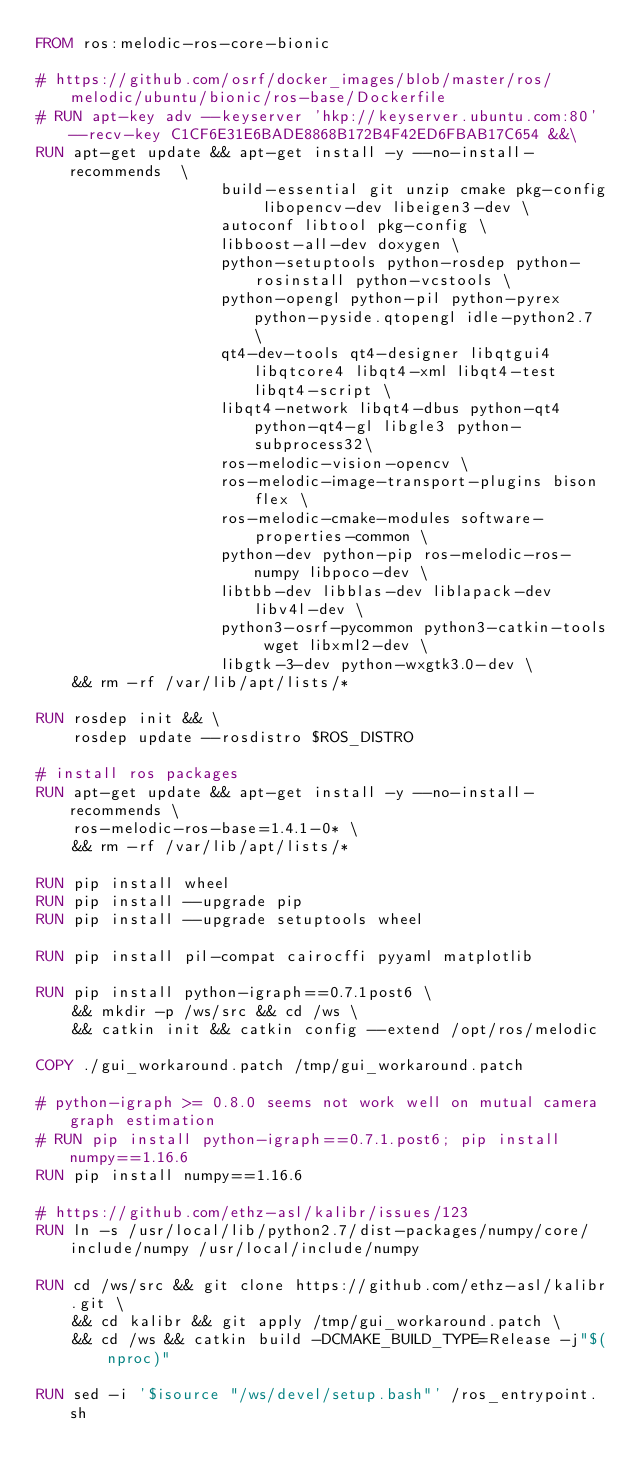Convert code to text. <code><loc_0><loc_0><loc_500><loc_500><_Dockerfile_>FROM ros:melodic-ros-core-bionic

# https://github.com/osrf/docker_images/blob/master/ros/melodic/ubuntu/bionic/ros-base/Dockerfile
# RUN apt-key adv --keyserver 'hkp://keyserver.ubuntu.com:80' --recv-key C1CF6E31E6BADE8868B172B4F42ED6FBAB17C654 &&\
RUN apt-get update && apt-get install -y --no-install-recommends  \
                    build-essential git unzip cmake pkg-config libopencv-dev libeigen3-dev \
                    autoconf libtool pkg-config \
                    libboost-all-dev doxygen \
                    python-setuptools python-rosdep python-rosinstall python-vcstools \
                    python-opengl python-pil python-pyrex python-pyside.qtopengl idle-python2.7 \
                    qt4-dev-tools qt4-designer libqtgui4 libqtcore4 libqt4-xml libqt4-test libqt4-script \
                    libqt4-network libqt4-dbus python-qt4 python-qt4-gl libgle3 python-subprocess32\
                    ros-melodic-vision-opencv \
                    ros-melodic-image-transport-plugins bison flex \
                    ros-melodic-cmake-modules software-properties-common \
                    python-dev python-pip ros-melodic-ros-numpy libpoco-dev \
                    libtbb-dev libblas-dev liblapack-dev libv4l-dev \
                    python3-osrf-pycommon python3-catkin-tools wget libxml2-dev \
                    libgtk-3-dev python-wxgtk3.0-dev \
    && rm -rf /var/lib/apt/lists/*

RUN rosdep init && \
    rosdep update --rosdistro $ROS_DISTRO

# install ros packages
RUN apt-get update && apt-get install -y --no-install-recommends \
    ros-melodic-ros-base=1.4.1-0* \
    && rm -rf /var/lib/apt/lists/*

RUN pip install wheel
RUN pip install --upgrade pip
RUN pip install --upgrade setuptools wheel

RUN pip install pil-compat cairocffi pyyaml matplotlib

RUN pip install python-igraph==0.7.1post6 \
    && mkdir -p /ws/src && cd /ws \
    && catkin init && catkin config --extend /opt/ros/melodic

COPY ./gui_workaround.patch /tmp/gui_workaround.patch

# python-igraph >= 0.8.0 seems not work well on mutual camera graph estimation
# RUN pip install python-igraph==0.7.1.post6; pip install numpy==1.16.6
RUN pip install numpy==1.16.6

# https://github.com/ethz-asl/kalibr/issues/123
RUN ln -s /usr/local/lib/python2.7/dist-packages/numpy/core/include/numpy /usr/local/include/numpy

RUN cd /ws/src && git clone https://github.com/ethz-asl/kalibr.git \
    && cd kalibr && git apply /tmp/gui_workaround.patch \
    && cd /ws && catkin build -DCMAKE_BUILD_TYPE=Release -j"$(nproc)"

RUN sed -i '$isource "/ws/devel/setup.bash"' /ros_entrypoint.sh</code> 